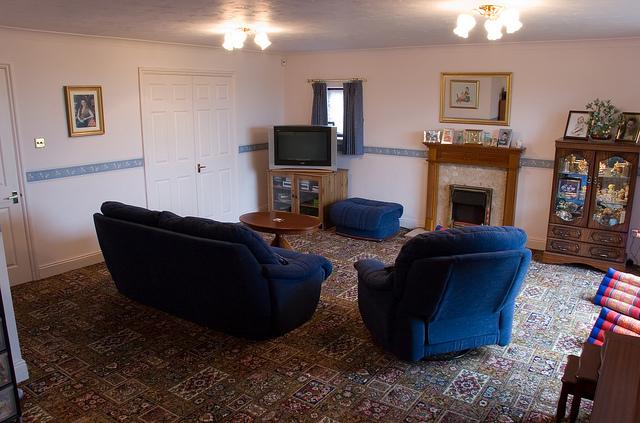Is this a hotel room?
Quick response, please. No. What material are the chair and ottoman made out of?
Short answer required. Cloth. Does the chair recline?
Answer briefly. Yes. What is sitting next to the television?
Answer briefly. Ottoman. Are the doors open?
Be succinct. No. Does this room have surround sound?
Give a very brief answer. No. What color are the couches?
Be succinct. Blue. What pattern is on the carpet?
Write a very short answer. Square. 